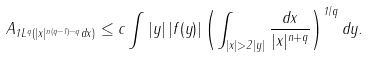<formula> <loc_0><loc_0><loc_500><loc_500>\| { A } _ { 1 } \| _ { L ^ { q } ( | x | ^ { n ( q - 1 ) - q } d x ) } \leq c \int | y | \, | { f } ( y ) | \left ( \int _ { | x | > 2 | y | } \frac { d x } { | x | ^ { n + q } } \right ) ^ { 1 / q } d y .</formula> 